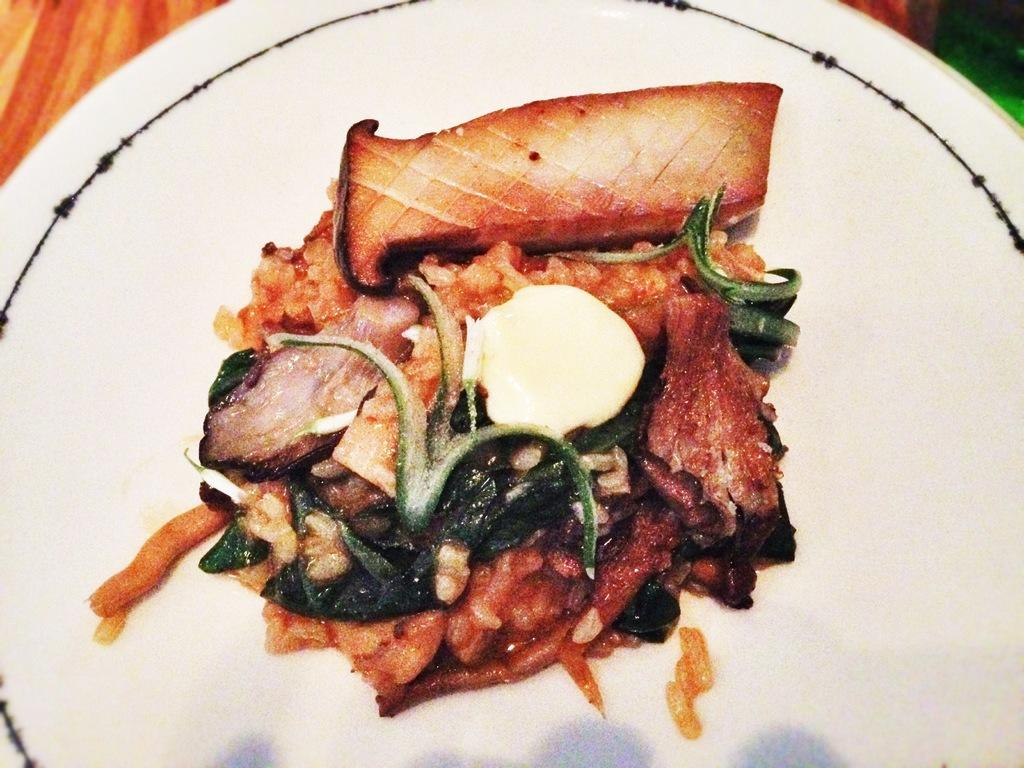What is on the plate in the image? There is a plate containing food in the image. What type of flowers are arranged on the zinc plate in the image? There are no flowers or zinc plate present in the image; it features a plate containing food. 